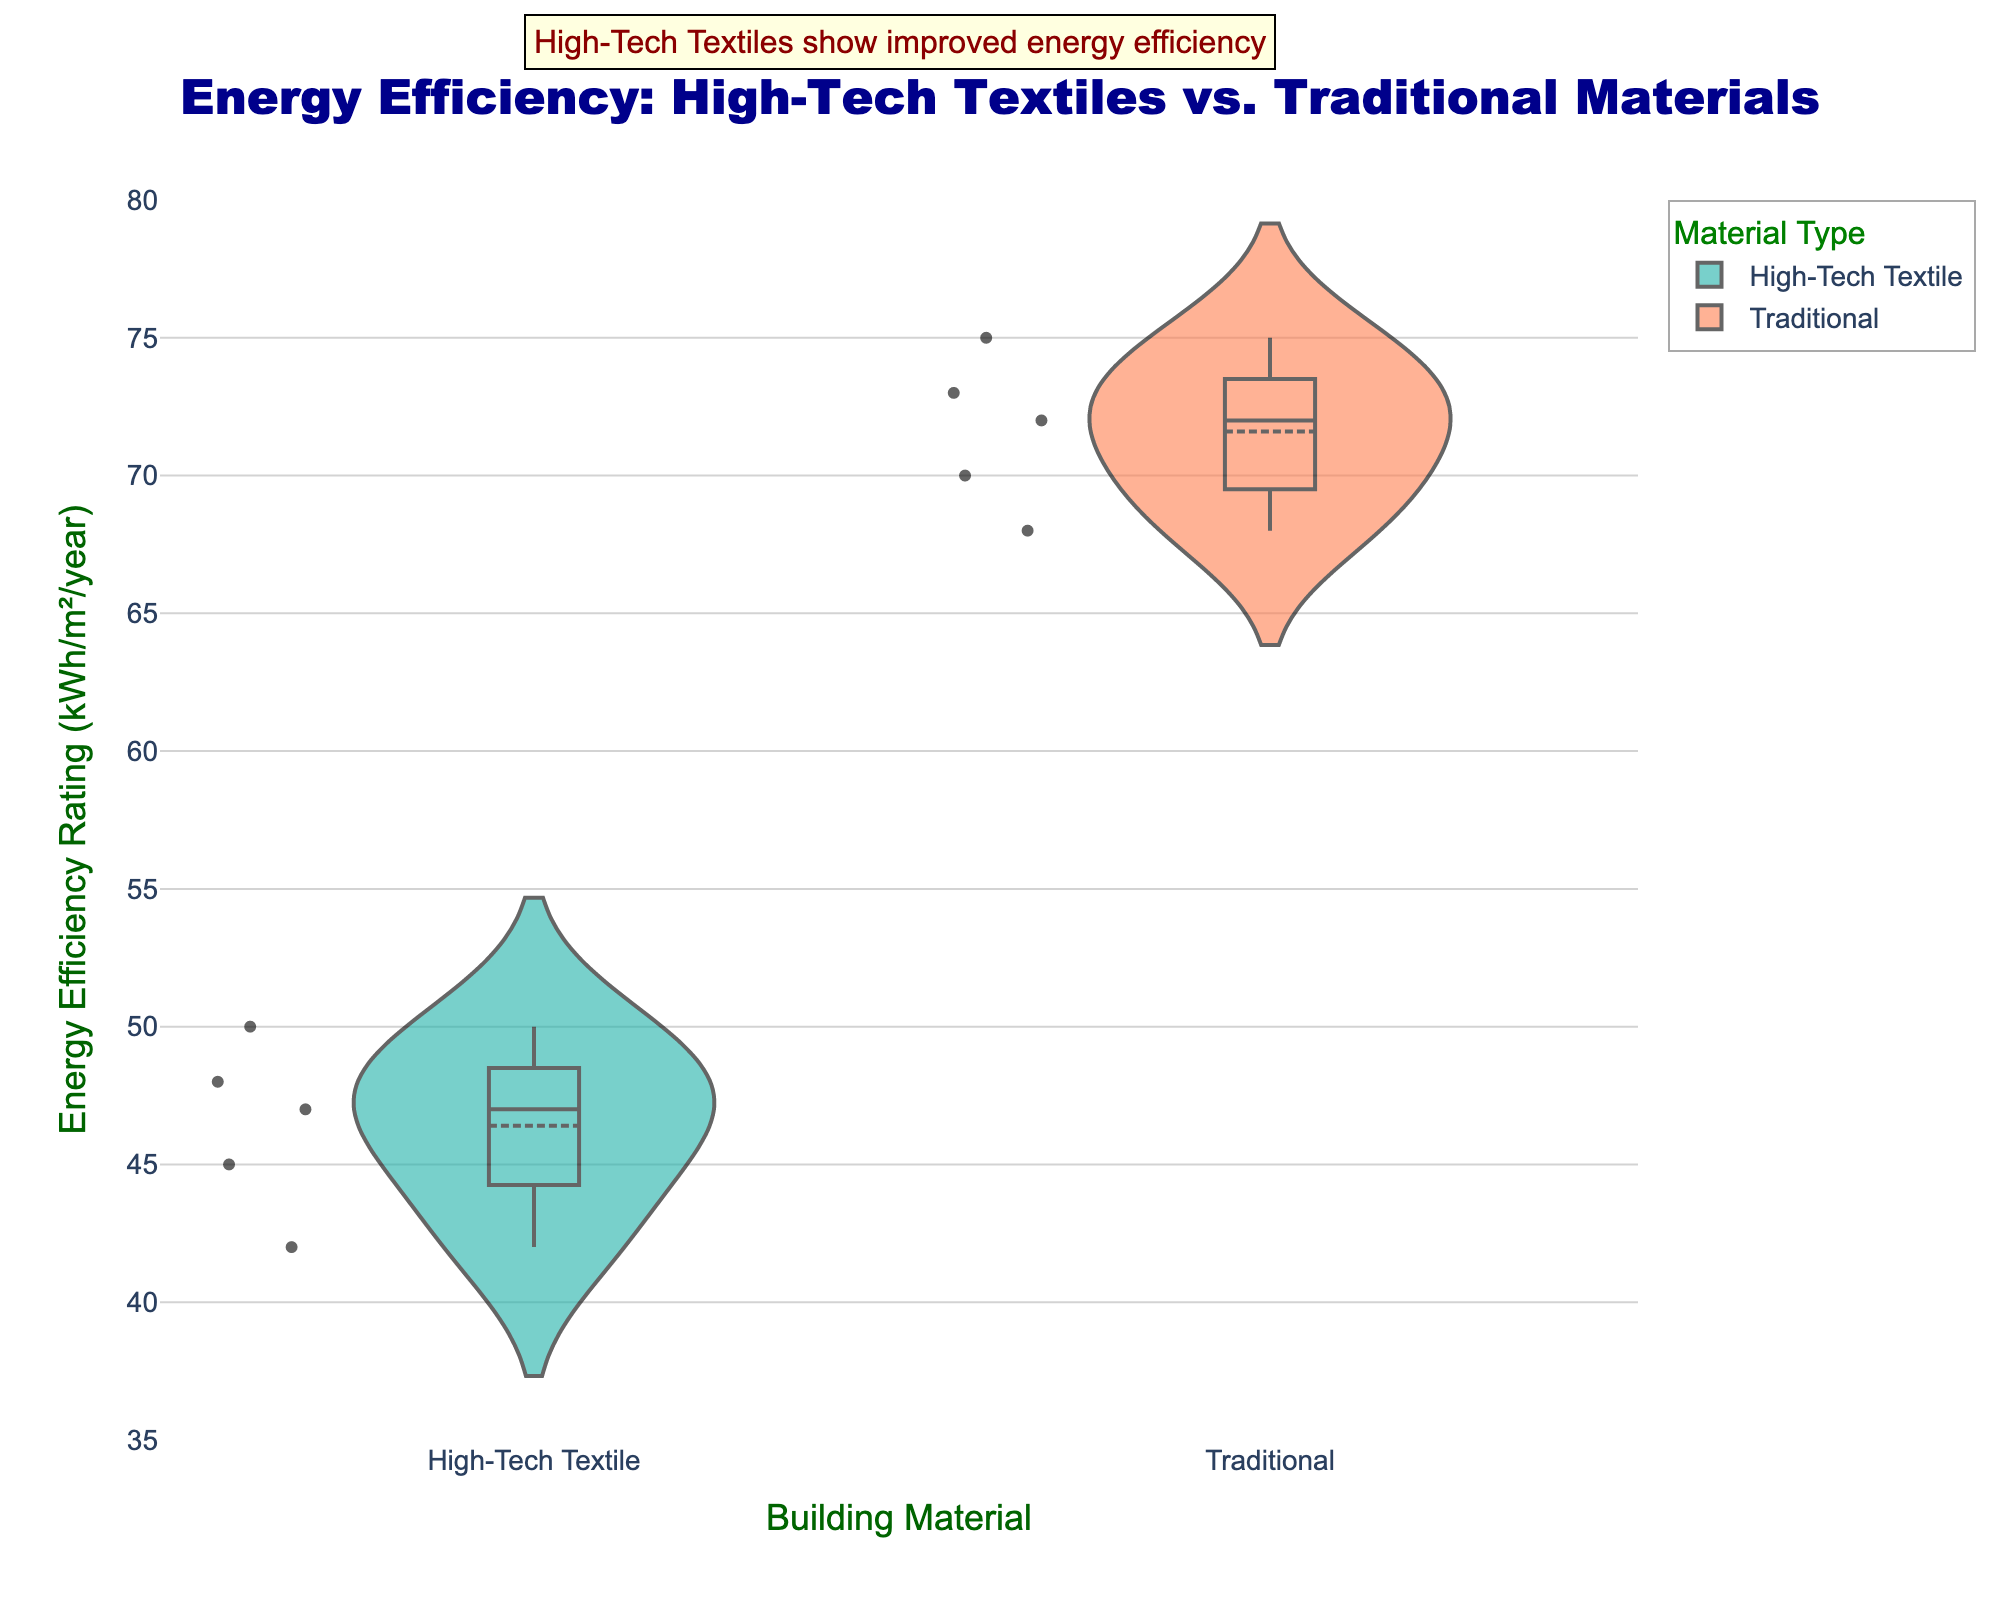What is the title of the figure? The title is usually displayed at the top of the figure. Here, the title text says "Energy Efficiency: High-Tech Textiles vs. Traditional Materials."
Answer: Energy Efficiency: High-Tech Textiles vs. Traditional Materials What do the x and y axes represent in this chart? The x-axis title is "Building Material," showing the different materials used in construction, while the y-axis title is "Energy Efficiency Rating (kWh/m^2/year)," representing the energy efficiency rating.
Answer: Building Material; Energy Efficiency Rating (kWh/m^2/year) Which material has a lower median energy efficiency rating? By examining the median lines in the box plots of the violin chart, the High-Tech Textile group has a lower median energy efficiency rating compared to Traditional materials.
Answer: High-Tech Textile How many individual data points are there for each material? The number of data points can be counted from the individual points shown inside the violin plots. There are 5 data points for High-Tech Textile and 5 data points for Traditional materials.
Answer: 5 for both What is the range of energy efficiency ratings for both materials? The range can be determined by finding the lowest and highest points in the violin plots for each material. For High-Tech Textile, it ranges from 42 to 50 kWh/m^2/year; for Traditional, it ranges from 68 to 75 kWh/m^2/year.
Answer: 42-50 kWh/m^2/year for High-Tech Textile; 68-75 kWh/m^2/year for Traditional How does the interquartile range (IQR) compare between the two materials? The IQR can be seen as the length of the box in the box plots. High-Tech Textiles have a shorter IQR (between approximately 45 to 48 kWh/m^2/year) compared to Traditional materials (between approximately 70 to 73 kWh/m^2/year), indicating less variability in energy efficiency ratings.
Answer: High-Tech Textile has a shorter IQR Which material shows greater variability in energy efficiency ratings? Variability can be visually assessed by looking at the width and spread of the violin plots and the length of the box plots. The Traditional material shows greater variability as its violin plot is more spread out and its box plot has a larger range.
Answer: Traditional What is the mean energy efficiency rating for Traditional materials based on the chart? In this violin plot, the mean line is visible inside the violin shapes. The mean for Traditional materials is approximately around 71-72 kWh/m^2/year, based on the location of the mean line within its violin plot.
Answer: Approximately 71-72 kWh/m^2/year What additional information does the annotation at the top provide? The annotation states, "High-Tech Textiles show improved energy efficiency," giving a qualitative assessment that supports the visual evidence of lower median and mean values for High-Tech Textiles.
Answer: High-Tech Textiles show improved energy efficiency What visual elements indicate that High-Tech Textiles are more energy-efficient overall? The combination of lower median and mean lines, a lower overall range, and a more compact interquartile range for High-Tech Textiles suggest they are more energy-efficient. These elements are visually more pronounced for High-Tech Textiles compared to Traditional materials.
Answer: Lower median, mean, range, and IQR for High-Tech Textiles 